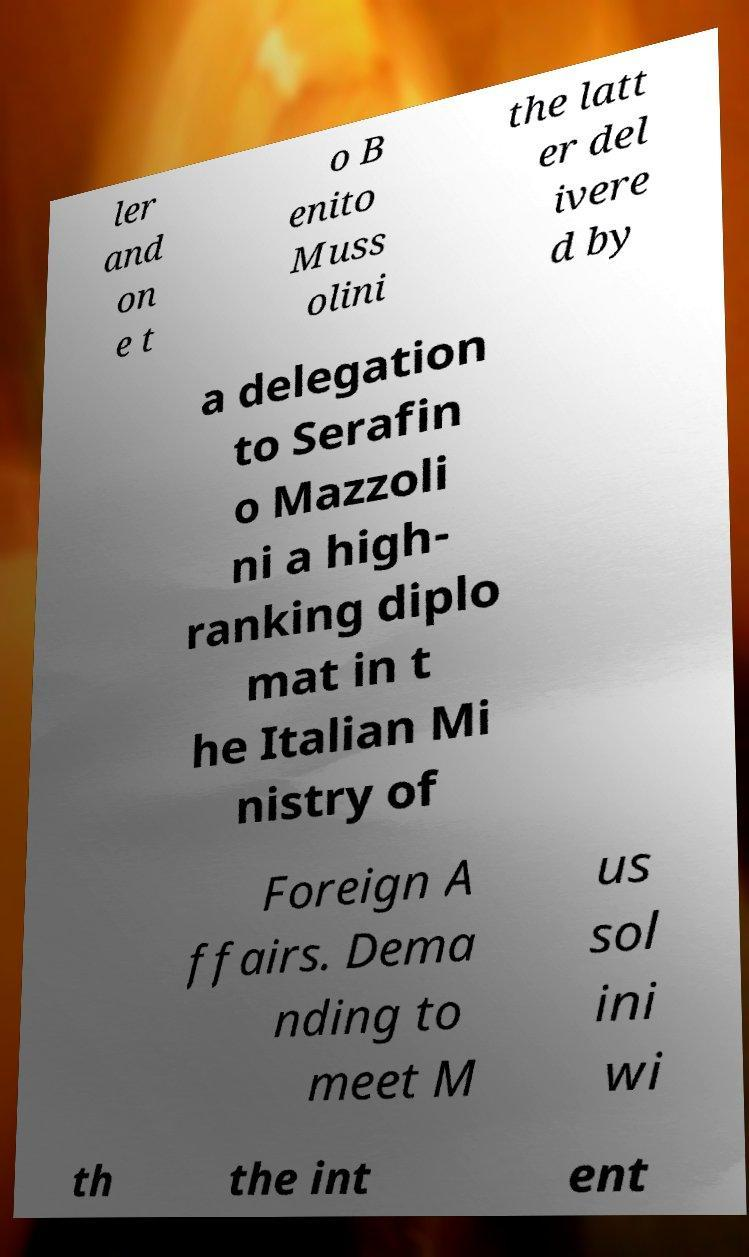I need the written content from this picture converted into text. Can you do that? ler and on e t o B enito Muss olini the latt er del ivere d by a delegation to Serafin o Mazzoli ni a high- ranking diplo mat in t he Italian Mi nistry of Foreign A ffairs. Dema nding to meet M us sol ini wi th the int ent 